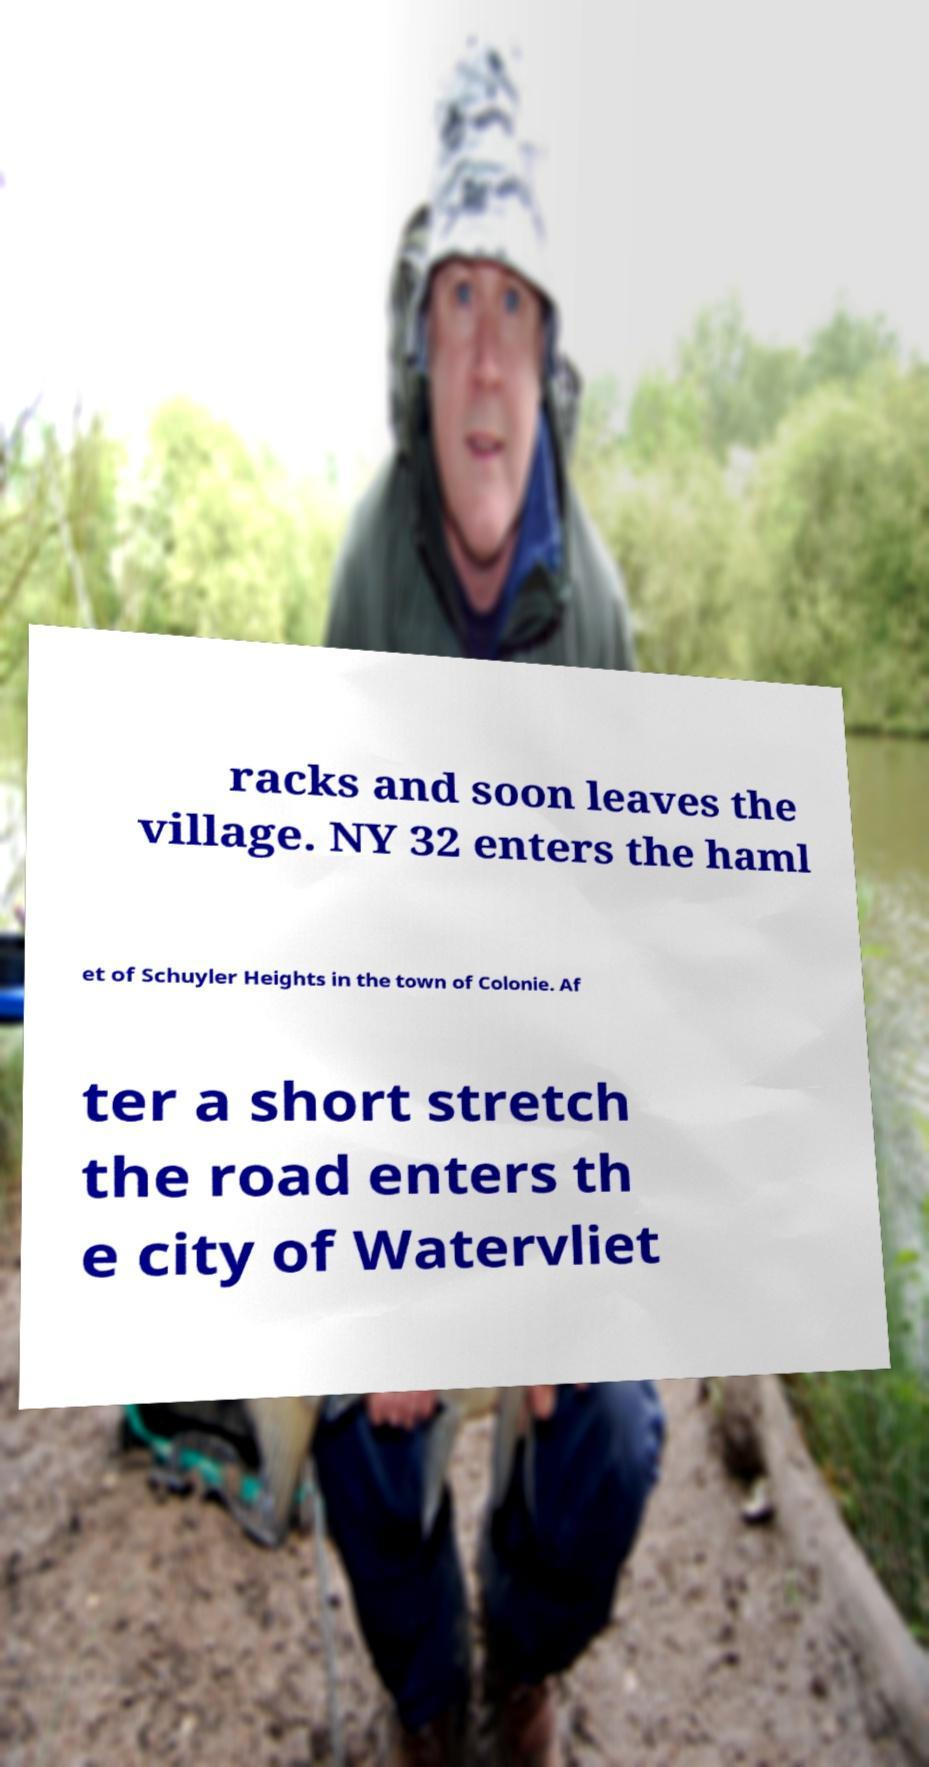What messages or text are displayed in this image? I need them in a readable, typed format. racks and soon leaves the village. NY 32 enters the haml et of Schuyler Heights in the town of Colonie. Af ter a short stretch the road enters th e city of Watervliet 